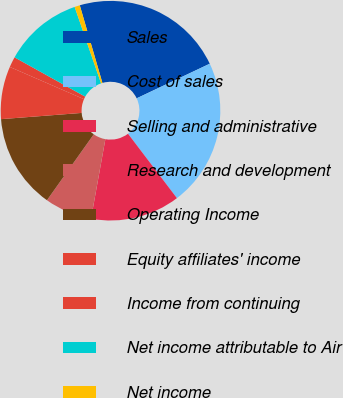<chart> <loc_0><loc_0><loc_500><loc_500><pie_chart><fcel>Sales<fcel>Cost of sales<fcel>Selling and administrative<fcel>Research and development<fcel>Operating Income<fcel>Equity affiliates' income<fcel>Income from continuing<fcel>Net income attributable to Air<fcel>Net income<nl><fcel>22.48%<fcel>21.7%<fcel>13.18%<fcel>6.98%<fcel>13.95%<fcel>7.75%<fcel>1.55%<fcel>11.63%<fcel>0.78%<nl></chart> 